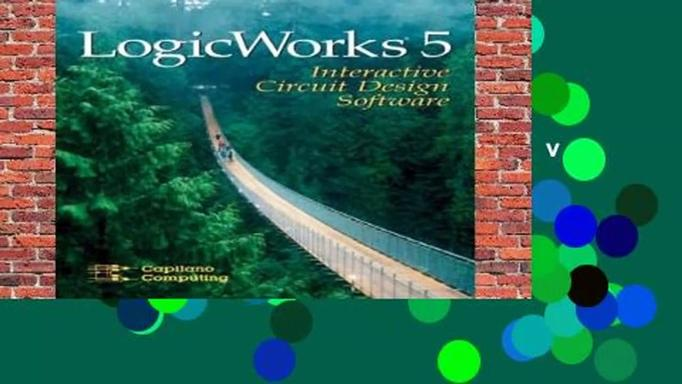Can you explain what LogicWorks 5 is used for? LogicWorks 5 serves as an essential educational and professional tool for designing, simulating, and testing digital circuits. Its interactive platform is especially beneficial for electronics engineers, educators, and students aiming to deepen their understanding of digital electronics through practical application. The software provides a visual approach to learning and designing, which supports the comprehension of complex electronic circuitry and aids in the preparation for more advanced engineering challenges. 